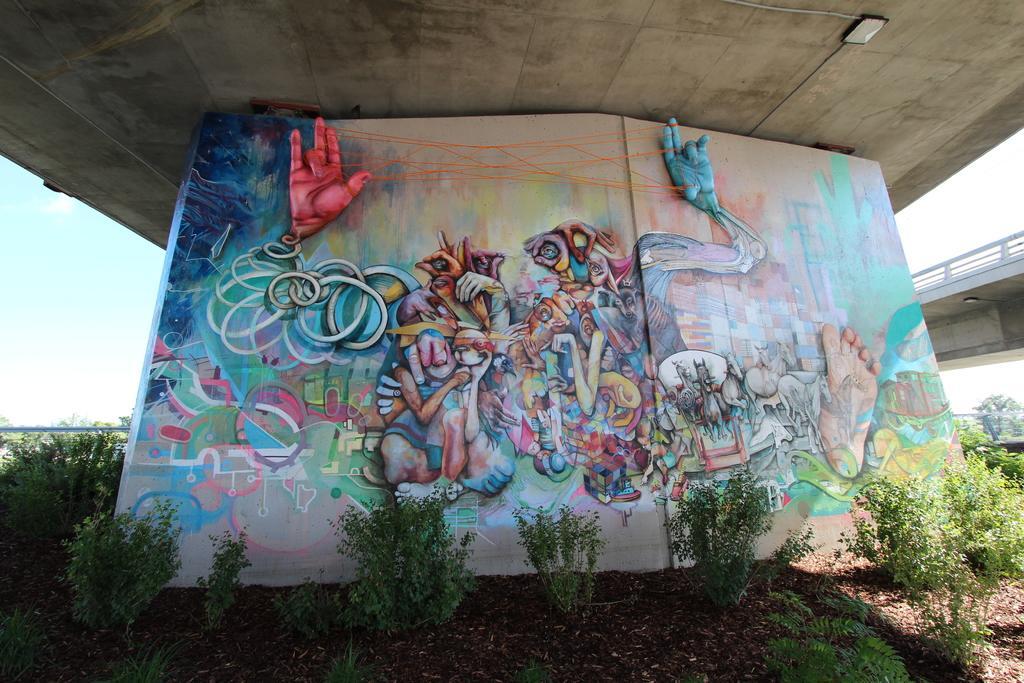Please provide a concise description of this image. In this picture we can see a wall with a painting on it, trees, bridge and in the background we can see sky with clouds. 